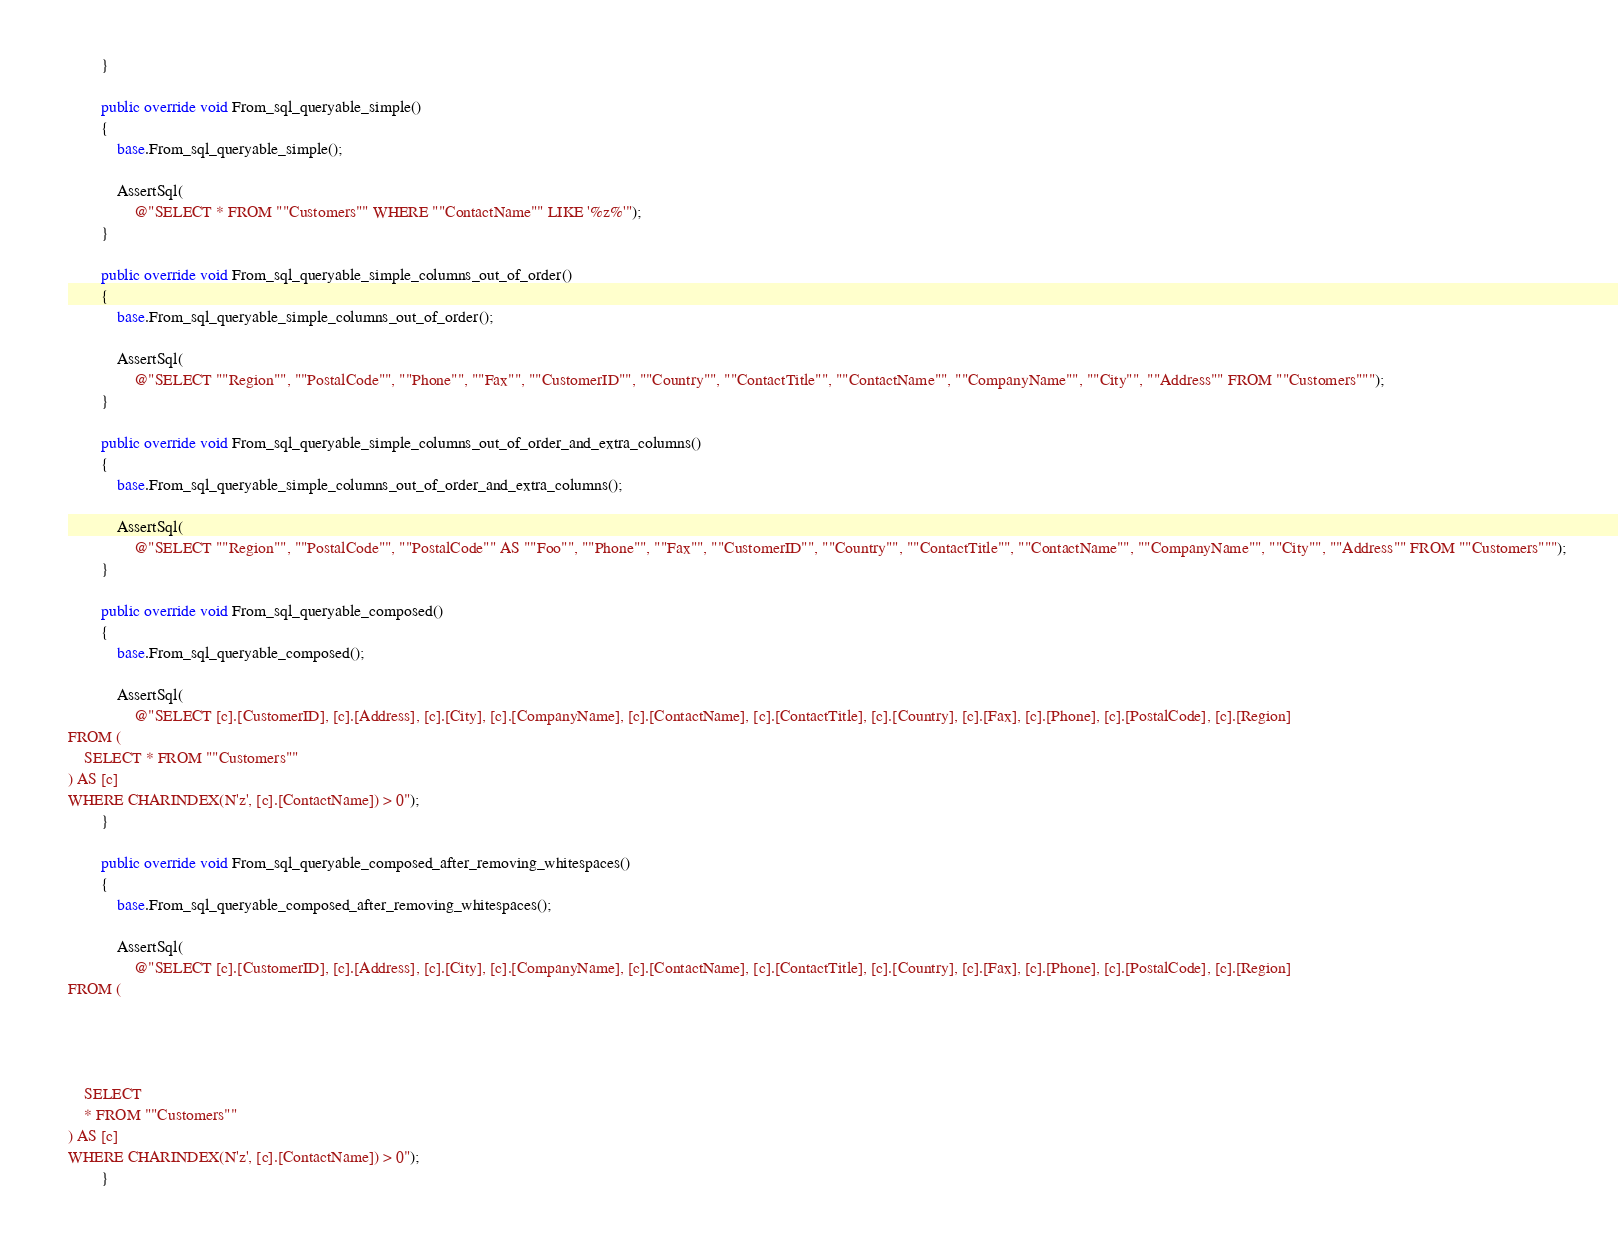Convert code to text. <code><loc_0><loc_0><loc_500><loc_500><_C#_>        }

        public override void From_sql_queryable_simple()
        {
            base.From_sql_queryable_simple();

            AssertSql(
                @"SELECT * FROM ""Customers"" WHERE ""ContactName"" LIKE '%z%'");
        }

        public override void From_sql_queryable_simple_columns_out_of_order()
        {
            base.From_sql_queryable_simple_columns_out_of_order();

            AssertSql(
                @"SELECT ""Region"", ""PostalCode"", ""Phone"", ""Fax"", ""CustomerID"", ""Country"", ""ContactTitle"", ""ContactName"", ""CompanyName"", ""City"", ""Address"" FROM ""Customers""");
        }

        public override void From_sql_queryable_simple_columns_out_of_order_and_extra_columns()
        {
            base.From_sql_queryable_simple_columns_out_of_order_and_extra_columns();

            AssertSql(
                @"SELECT ""Region"", ""PostalCode"", ""PostalCode"" AS ""Foo"", ""Phone"", ""Fax"", ""CustomerID"", ""Country"", ""ContactTitle"", ""ContactName"", ""CompanyName"", ""City"", ""Address"" FROM ""Customers""");
        }

        public override void From_sql_queryable_composed()
        {
            base.From_sql_queryable_composed();

            AssertSql(
                @"SELECT [c].[CustomerID], [c].[Address], [c].[City], [c].[CompanyName], [c].[ContactName], [c].[ContactTitle], [c].[Country], [c].[Fax], [c].[Phone], [c].[PostalCode], [c].[Region]
FROM (
    SELECT * FROM ""Customers""
) AS [c]
WHERE CHARINDEX(N'z', [c].[ContactName]) > 0");
        }

        public override void From_sql_queryable_composed_after_removing_whitespaces()
        {
            base.From_sql_queryable_composed_after_removing_whitespaces();

            AssertSql(
                @"SELECT [c].[CustomerID], [c].[Address], [c].[City], [c].[CompanyName], [c].[ContactName], [c].[ContactTitle], [c].[Country], [c].[Fax], [c].[Phone], [c].[PostalCode], [c].[Region]
FROM (

        


    SELECT
    * FROM ""Customers""
) AS [c]
WHERE CHARINDEX(N'z', [c].[ContactName]) > 0");
        }
</code> 